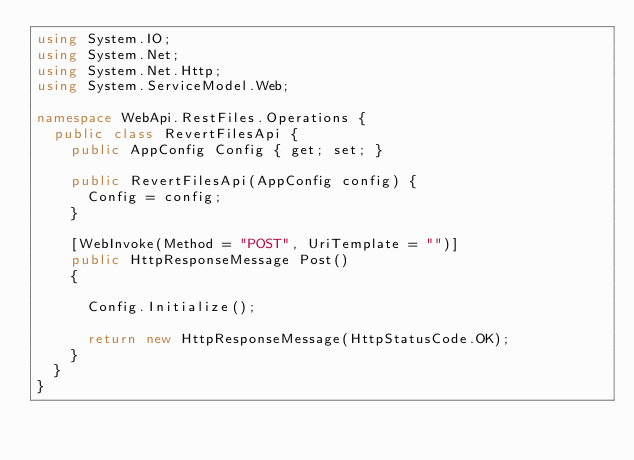Convert code to text. <code><loc_0><loc_0><loc_500><loc_500><_C#_>using System.IO;
using System.Net;
using System.Net.Http;
using System.ServiceModel.Web;

namespace WebApi.RestFiles.Operations {
	public class RevertFilesApi {
		public AppConfig Config { get; set; }

		public RevertFilesApi(AppConfig config) {
			Config = config;
		}

		[WebInvoke(Method = "POST", UriTemplate = "")]
		public HttpResponseMessage Post()
		{

			Config.Initialize();
			
			return new HttpResponseMessage(HttpStatusCode.OK);
		}
	}
}</code> 